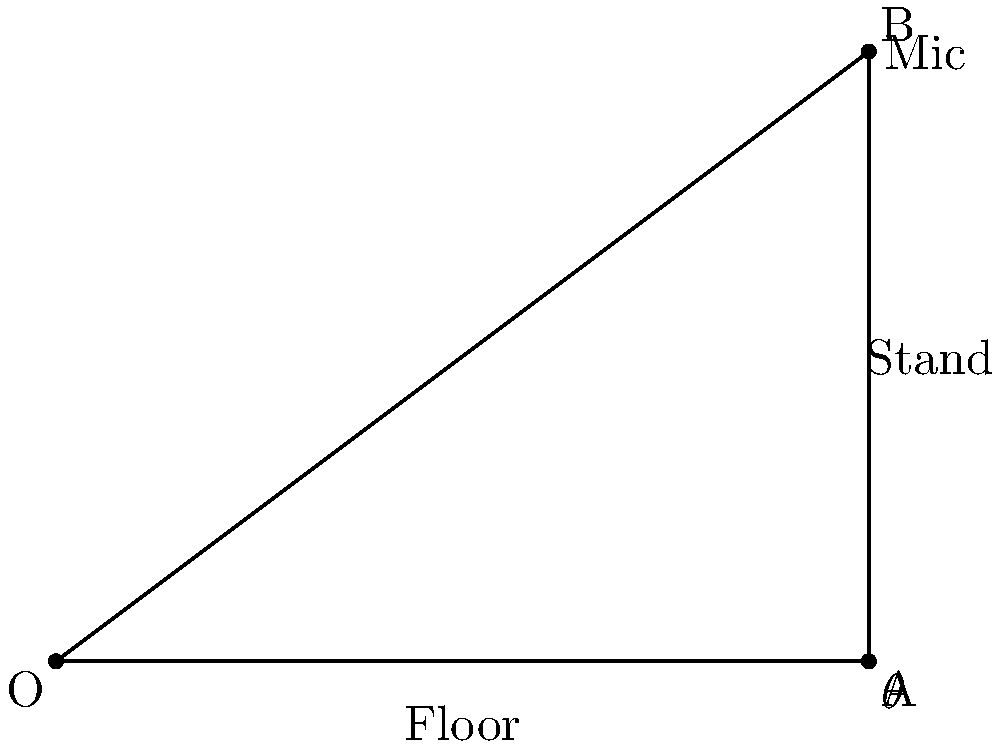In a rap performance, the microphone stand needs to be positioned at a specific angle for optimal sound capture. If the base of the stand is 4 feet from the performer, and the microphone is 3 feet above the floor, what is the angle $\theta$ (in degrees) between the floor and the microphone stand? To solve this problem, we'll use trigonometry. Let's approach this step-by-step:

1) The scenario forms a right-angled triangle, where:
   - The floor is the base (adjacent to the angle we're looking for)
   - The microphone stand is the hypotenuse
   - The vertical height of the mic is the opposite side

2) We know:
   - Adjacent (floor distance) = 4 feet
   - Opposite (mic height) = 3 feet

3) To find the angle, we can use the tangent function:

   $\tan(\theta) = \frac{\text{opposite}}{\text{adjacent}} = \frac{3}{4}$

4) To get $\theta$, we need to use the inverse tangent (arctan or $\tan^{-1}$):

   $\theta = \tan^{-1}(\frac{3}{4})$

5) Using a calculator or computer:

   $\theta \approx 36.87$ degrees

Therefore, the angle between the floor and the microphone stand is approximately 36.87 degrees.
Answer: $36.87°$ 